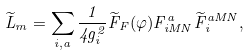<formula> <loc_0><loc_0><loc_500><loc_500>\widetilde { L } _ { m } = \sum _ { i , a } \frac { 1 } { 4 g _ { i } ^ { 2 } } \widetilde { F } _ { F } ( \varphi ) F _ { i M N } ^ { a } \widetilde { F } _ { i } ^ { a M N } ,</formula> 